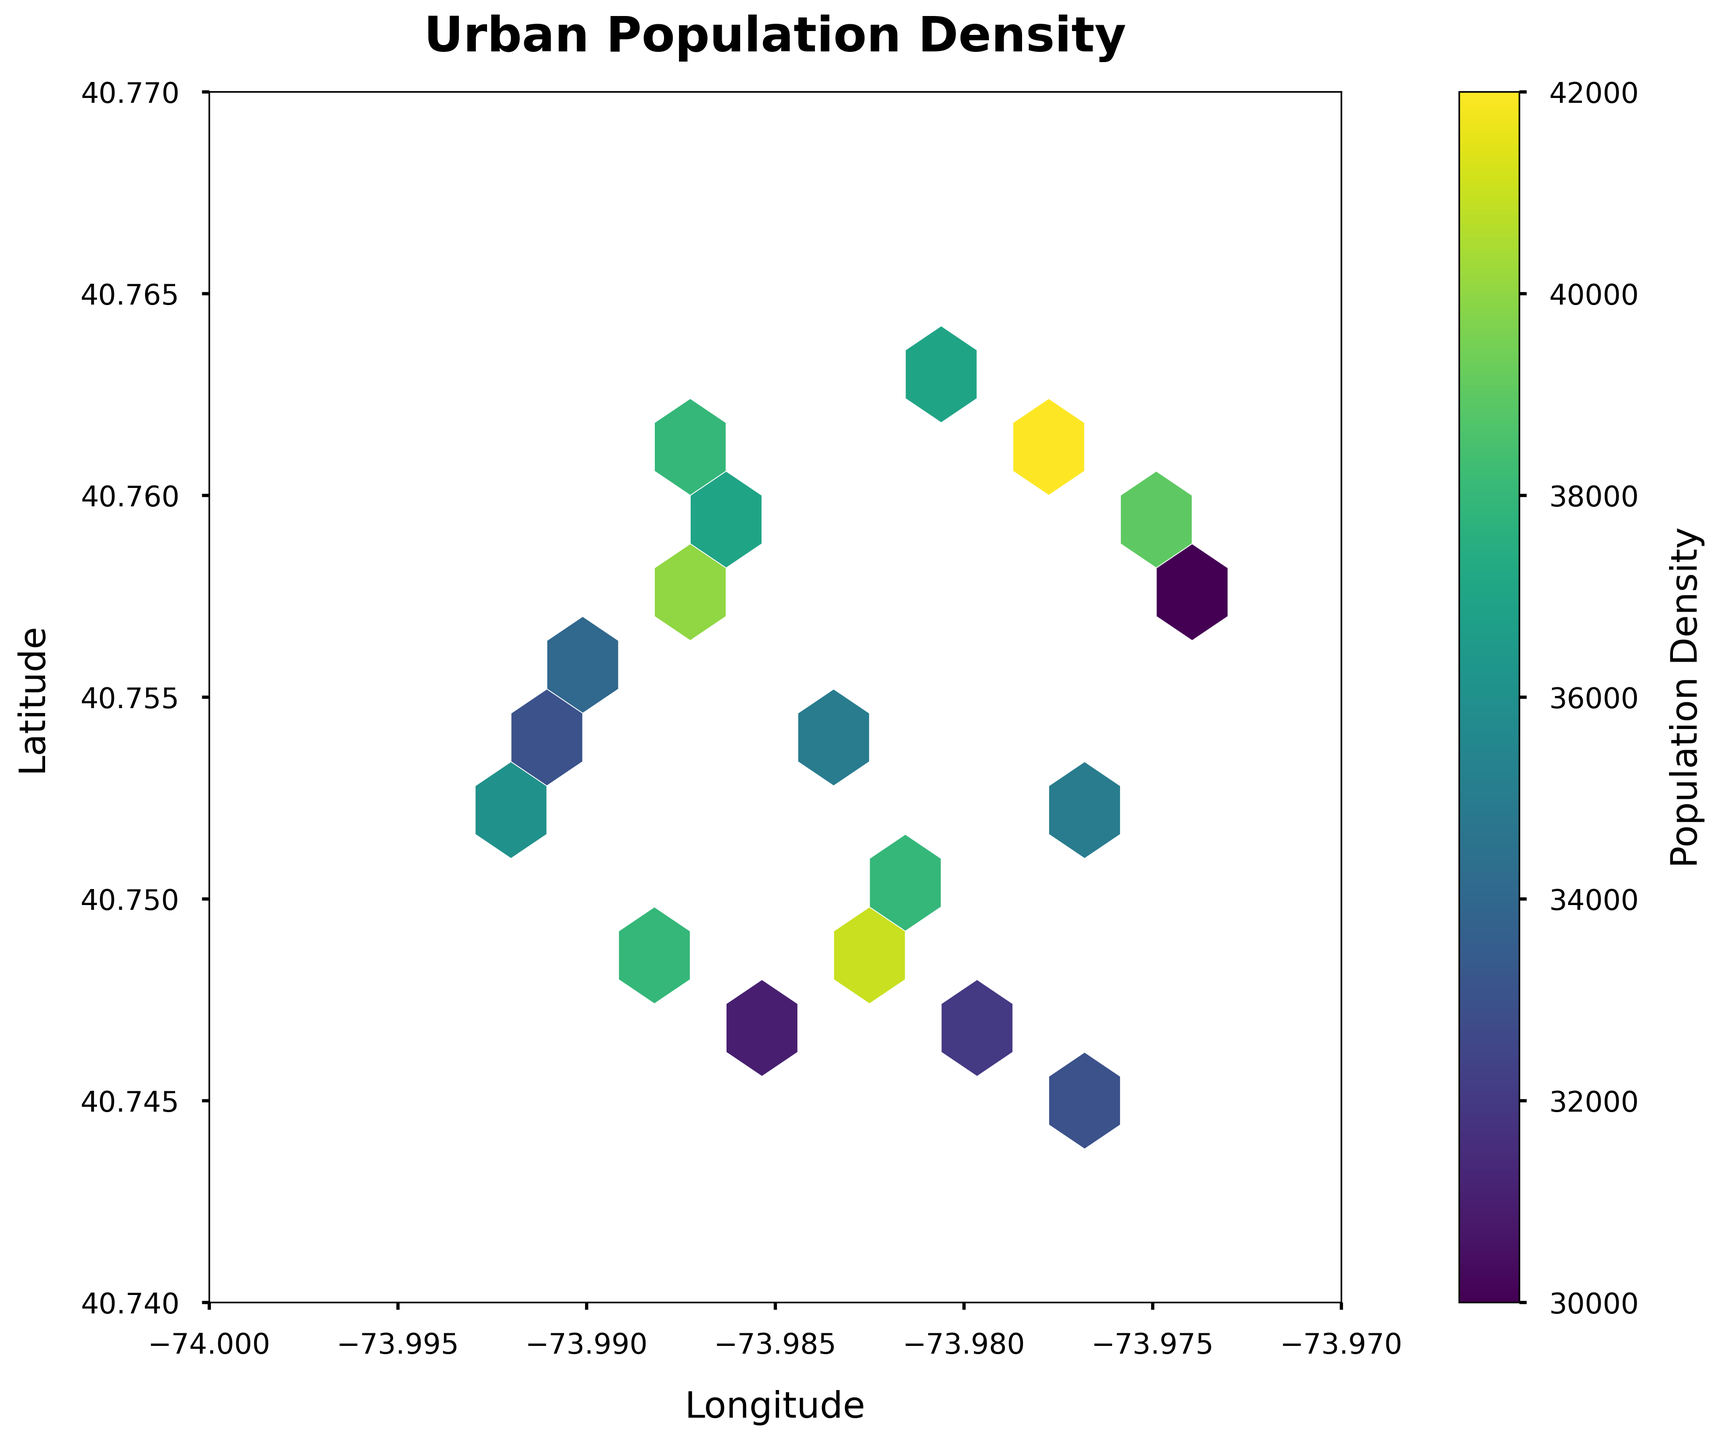What is the title of the hexbin plot? The title of the plot is displayed prominently at the top of the figure, which reads "Urban Population Density".
Answer: Urban Population Density What are the labels for the x-axis and y-axis? The x-axis label is "Longitude," and the y-axis label is "Latitude." These labels are displayed along the respective axes.
Answer: Longitude and Latitude How is the population density represented in the hexbin plot? The population density is represented using colors. The color bar on the right shows the gradation of colors representing different population densities, ranging from dark (low density) to light (high density).
Answer: Colors What is the range of the longitude values presented on the x-axis? The x-axis spans from -74.0 to -73.97, as shown by the tick marks at the bottom of the plot.
Answer: -74.0 to -73.97 What is the range of the latitude values presented on the y-axis? The y-axis spans from 40.74 to 40.77, as indicated by the tick marks along the left side of the plot.
Answer: 40.74 to 40.77 Which area has the highest population density based on the color gradient? By observing the hexbin plot, the brightest (lightest) colored hexagons represent the areas with the highest population density, which are centrally located around -73.98 longitude and 40.76 latitude.
Answer: Around -73.98 longitude and 40.76 latitude How many grid cells are used in the hexbin plot? The color map legend "grid size" mentioned that there are 10 grid cells utilized in the plot, shown by the hexagonal shapes dividing the plot area.
Answer: 10 Which neighborhood quadrant appears to have a higher population density, northwestern or southeastern? The northwestern quadrant (upper left) has brighter colors compared to the southeastern quadrant (lower right), indicating a higher population density.
Answer: Northwestern quadrant What seems to be the general trend in population density as you move northward in the plot? As you move northward (higher latitude) in the plot, there is a trend of increasing population density, indicated by the colors becoming lighter.
Answer: Increasing population density What is the population density in the area around -73.985 longitude and 40.754 latitude? By looking at the location mentioned and checking the corresponding color, we can use the color bar to find the approximate population density, which is around 35,000.
Answer: Approx. 35,000 